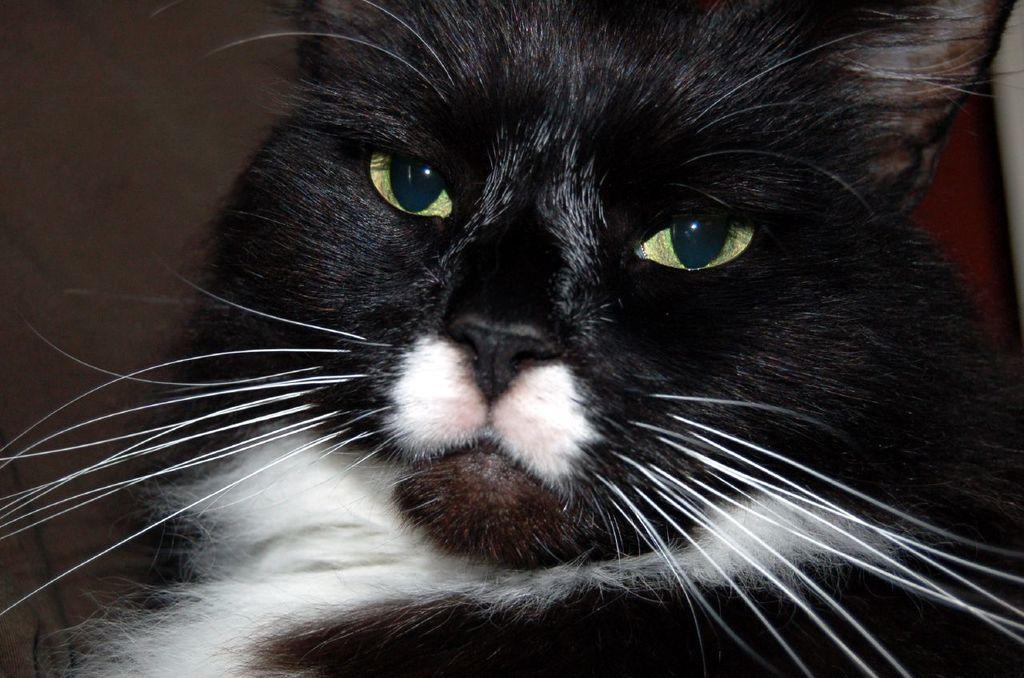In one or two sentences, can you explain what this image depicts? This image consists of a cat. It is in black color. It has eyes, nose, mouth, whisker. 